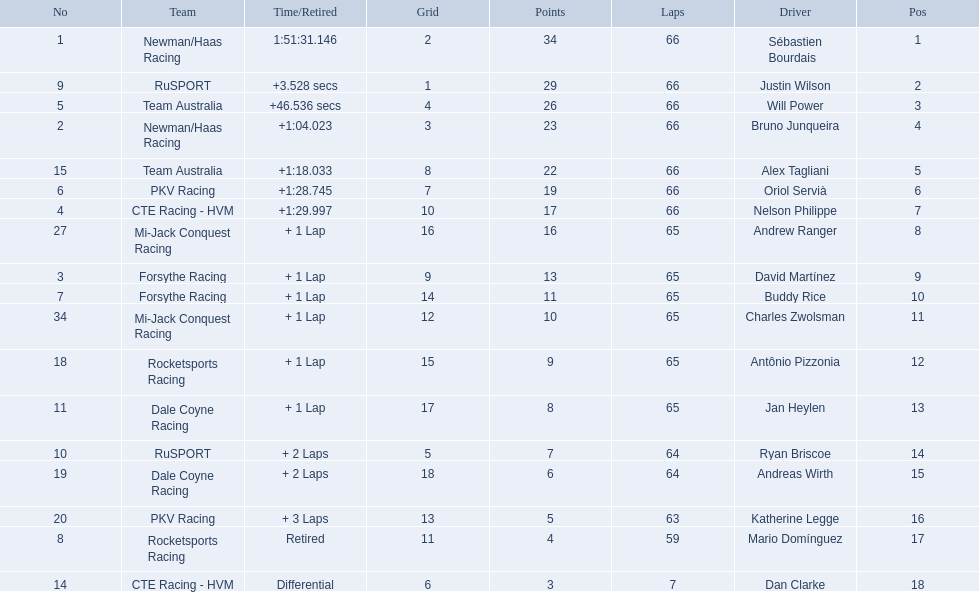Which teams participated in the 2006 gran premio telmex? Newman/Haas Racing, RuSPORT, Team Australia, Newman/Haas Racing, Team Australia, PKV Racing, CTE Racing - HVM, Mi-Jack Conquest Racing, Forsythe Racing, Forsythe Racing, Mi-Jack Conquest Racing, Rocketsports Racing, Dale Coyne Racing, RuSPORT, Dale Coyne Racing, PKV Racing, Rocketsports Racing, CTE Racing - HVM. Who were the drivers of these teams? Sébastien Bourdais, Justin Wilson, Will Power, Bruno Junqueira, Alex Tagliani, Oriol Servià, Nelson Philippe, Andrew Ranger, David Martínez, Buddy Rice, Charles Zwolsman, Antônio Pizzonia, Jan Heylen, Ryan Briscoe, Andreas Wirth, Katherine Legge, Mario Domínguez, Dan Clarke. Which driver finished last? Dan Clarke. 